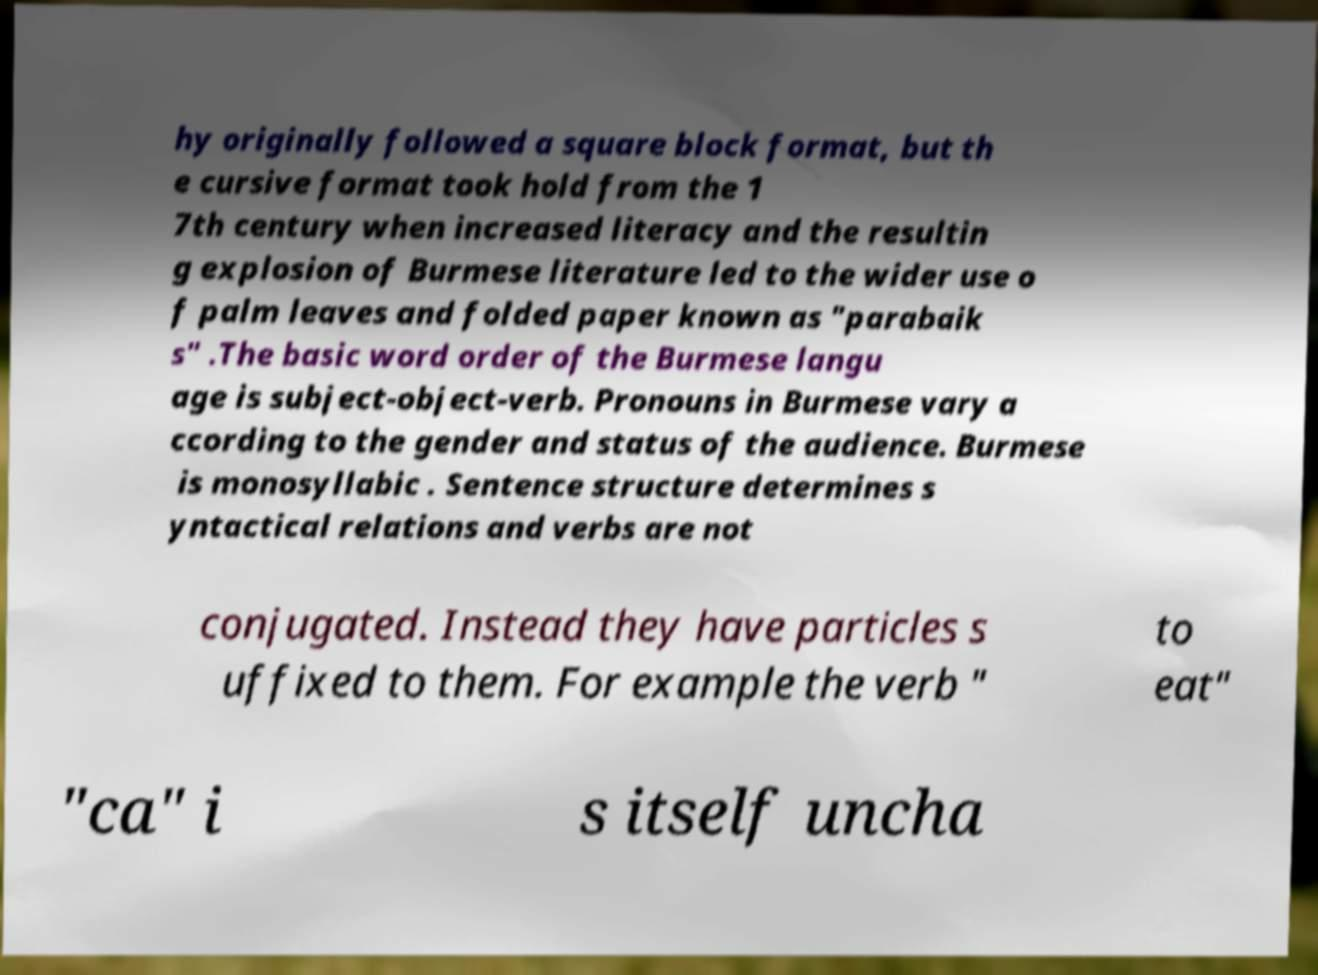Please identify and transcribe the text found in this image. hy originally followed a square block format, but th e cursive format took hold from the 1 7th century when increased literacy and the resultin g explosion of Burmese literature led to the wider use o f palm leaves and folded paper known as "parabaik s" .The basic word order of the Burmese langu age is subject-object-verb. Pronouns in Burmese vary a ccording to the gender and status of the audience. Burmese is monosyllabic . Sentence structure determines s yntactical relations and verbs are not conjugated. Instead they have particles s uffixed to them. For example the verb " to eat" "ca" i s itself uncha 